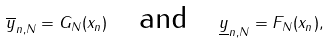<formula> <loc_0><loc_0><loc_500><loc_500>\overline { y } _ { n , N } = G _ { N } ( x _ { n } ) \quad \text {and} \quad \underline { y } _ { n , N } = F _ { N } ( x _ { n } ) ,</formula> 